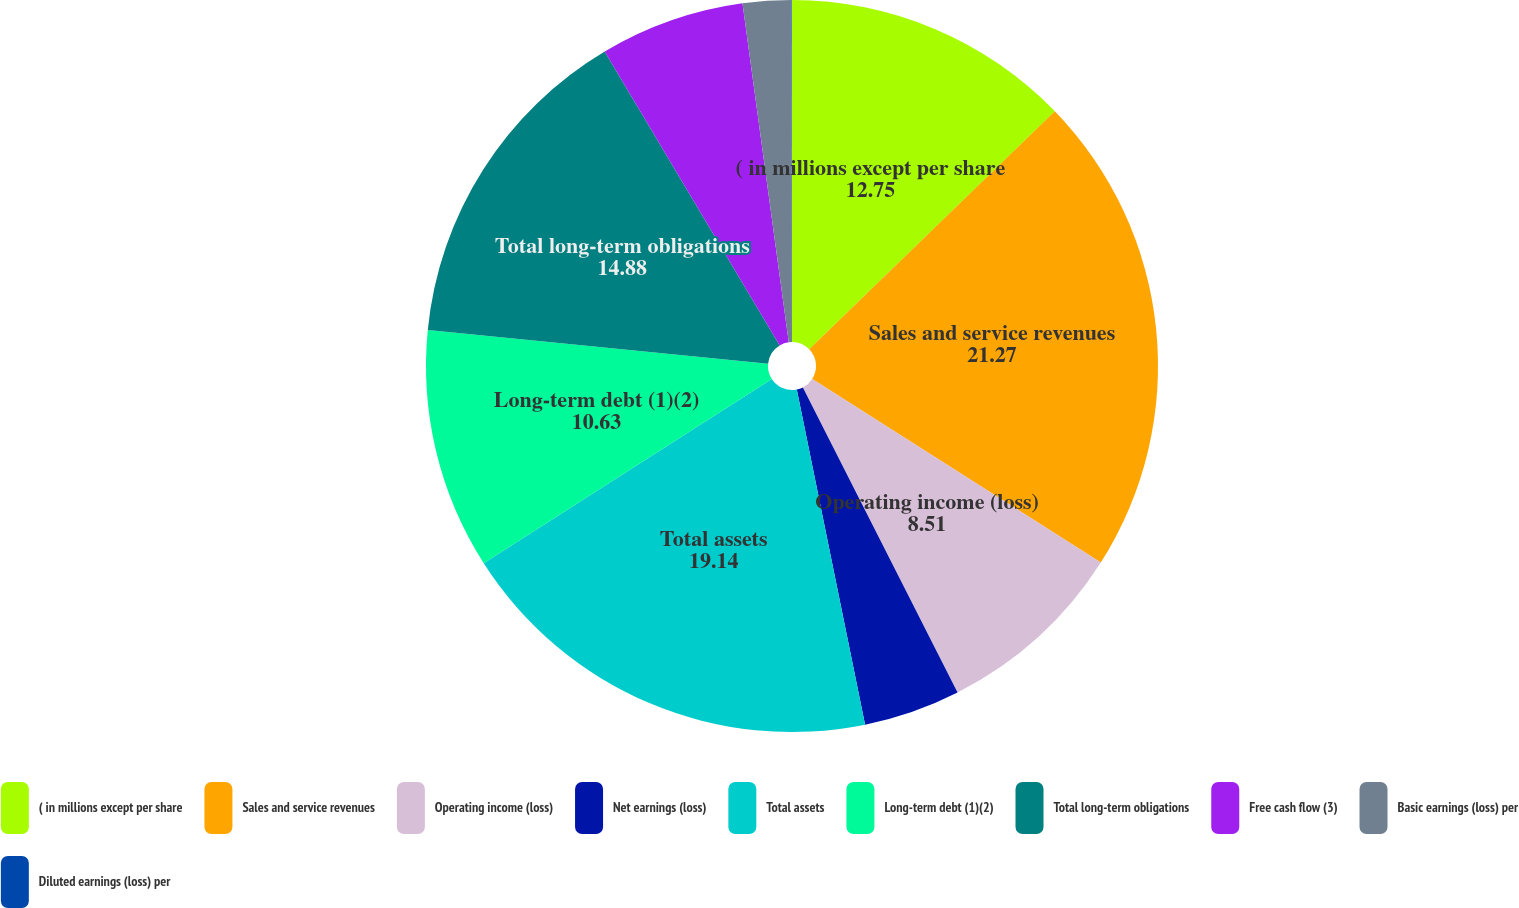Convert chart to OTSL. <chart><loc_0><loc_0><loc_500><loc_500><pie_chart><fcel>( in millions except per share<fcel>Sales and service revenues<fcel>Operating income (loss)<fcel>Net earnings (loss)<fcel>Total assets<fcel>Long-term debt (1)(2)<fcel>Total long-term obligations<fcel>Free cash flow (3)<fcel>Basic earnings (loss) per<fcel>Diluted earnings (loss) per<nl><fcel>12.75%<fcel>21.27%<fcel>8.51%<fcel>4.27%<fcel>19.14%<fcel>10.63%<fcel>14.88%<fcel>6.39%<fcel>2.14%<fcel>0.02%<nl></chart> 